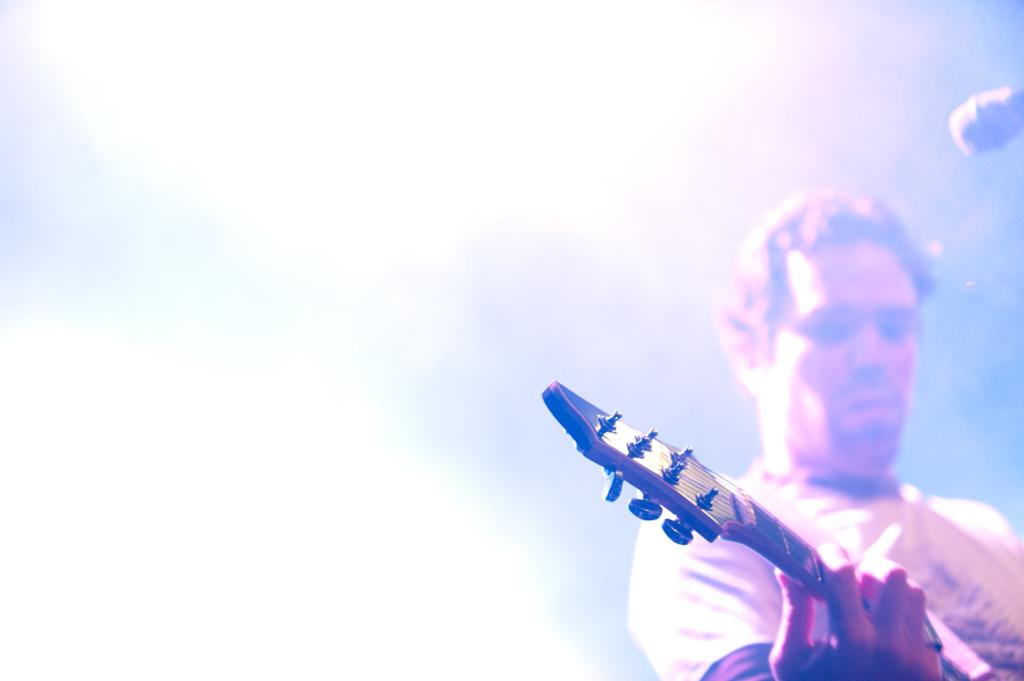Who is the main subject in the image? There is a man in the image. What is the man holding in the image? The man is holding a guitar. What object is in front of the man? There is a microphone in front of the man. What is the color of the background in the image? The background of the image is white. What type of doctor is standing next to the man in the image? There is no doctor present in the image. How many women are visible in the image? There are no women visible in the image. 